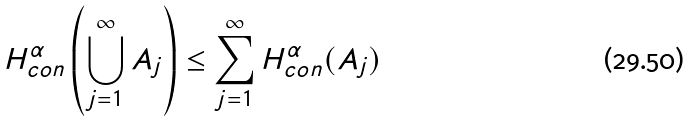<formula> <loc_0><loc_0><loc_500><loc_500>H ^ { \alpha } _ { c o n } \left ( \bigcup _ { j = 1 } ^ { \infty } A _ { j } \right ) \leq \sum _ { j = 1 } ^ { \infty } H ^ { \alpha } _ { c o n } ( A _ { j } )</formula> 